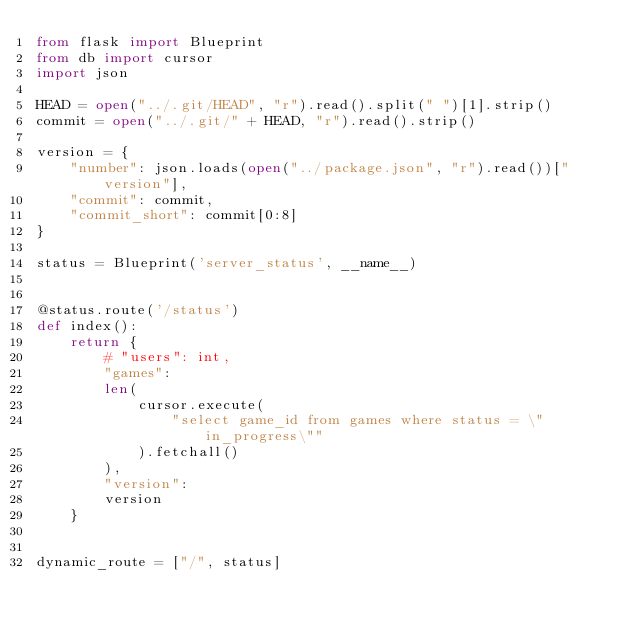<code> <loc_0><loc_0><loc_500><loc_500><_Python_>from flask import Blueprint
from db import cursor
import json

HEAD = open("../.git/HEAD", "r").read().split(" ")[1].strip()
commit = open("../.git/" + HEAD, "r").read().strip()

version = {
    "number": json.loads(open("../package.json", "r").read())["version"],
    "commit": commit,
    "commit_short": commit[0:8]
}

status = Blueprint('server_status', __name__)


@status.route('/status')
def index():
    return {
        # "users": int,
        "games":
        len(
            cursor.execute(
                "select game_id from games where status = \"in_progress\""
            ).fetchall()
        ),
        "version":
        version
    }


dynamic_route = ["/", status]
</code> 